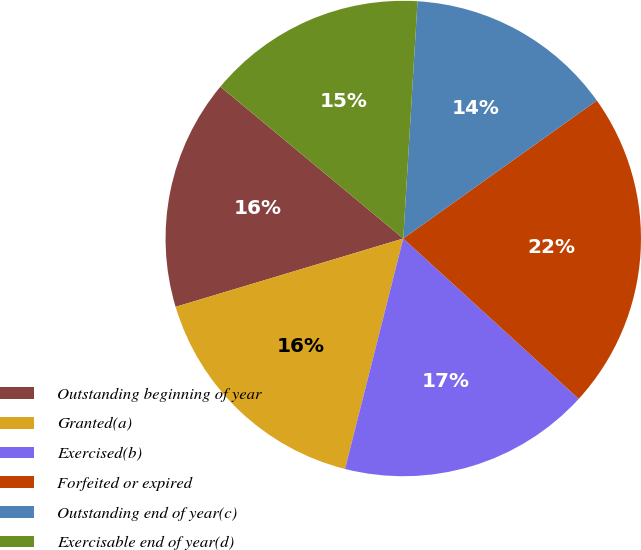Convert chart. <chart><loc_0><loc_0><loc_500><loc_500><pie_chart><fcel>Outstanding beginning of year<fcel>Granted(a)<fcel>Exercised(b)<fcel>Forfeited or expired<fcel>Outstanding end of year(c)<fcel>Exercisable end of year(d)<nl><fcel>15.67%<fcel>16.42%<fcel>17.16%<fcel>21.64%<fcel>14.19%<fcel>14.93%<nl></chart> 